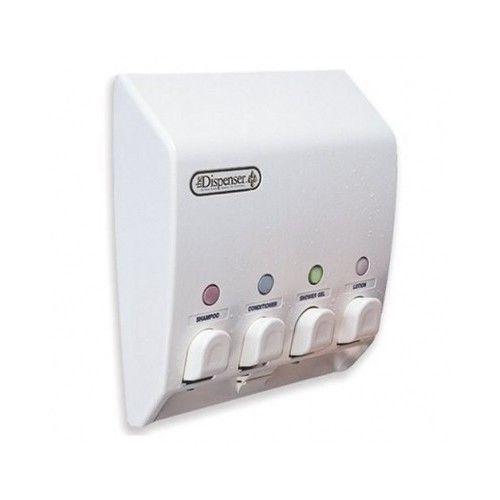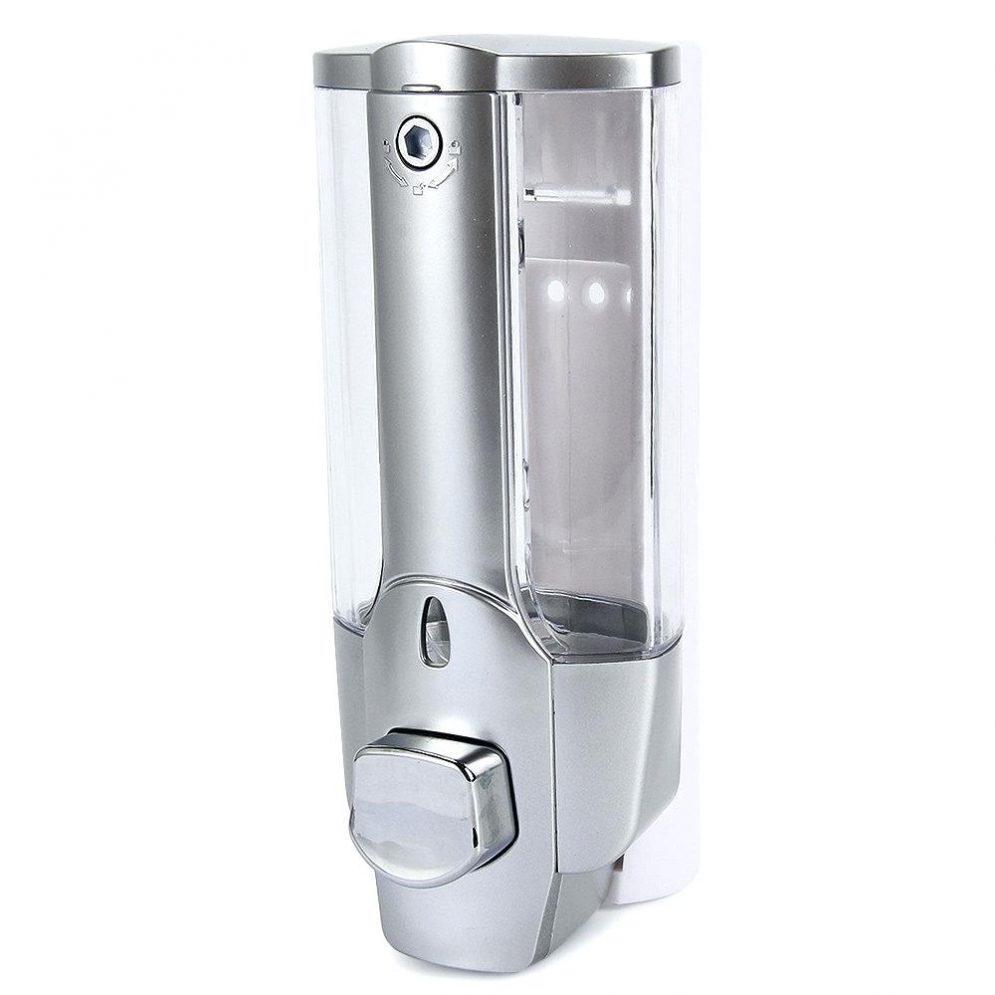The first image is the image on the left, the second image is the image on the right. Examine the images to the left and right. Is the description "there is exactly one dispensing button in one of the images" accurate? Answer yes or no. Yes. 